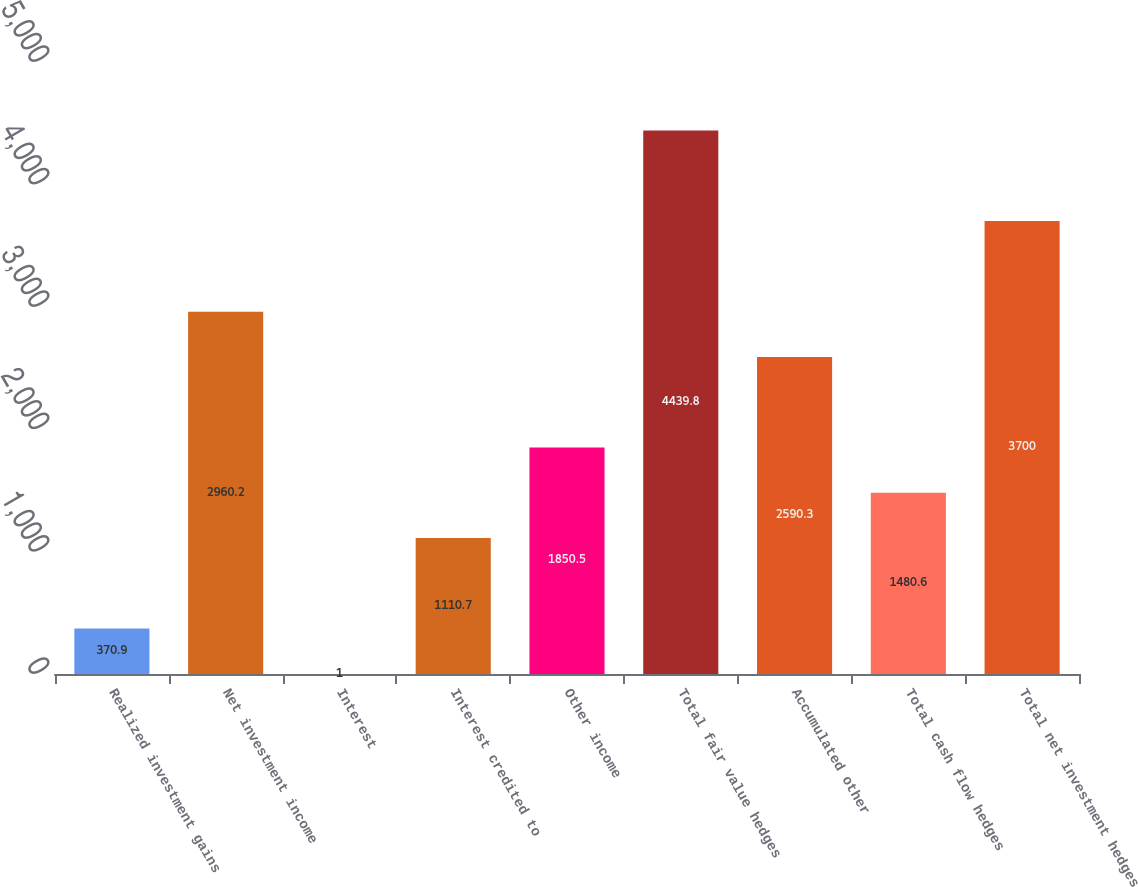Convert chart. <chart><loc_0><loc_0><loc_500><loc_500><bar_chart><fcel>Realized investment gains<fcel>Net investment income<fcel>Interest<fcel>Interest credited to<fcel>Other income<fcel>Total fair value hedges<fcel>Accumulated other<fcel>Total cash flow hedges<fcel>Total net investment hedges<nl><fcel>370.9<fcel>2960.2<fcel>1<fcel>1110.7<fcel>1850.5<fcel>4439.8<fcel>2590.3<fcel>1480.6<fcel>3700<nl></chart> 